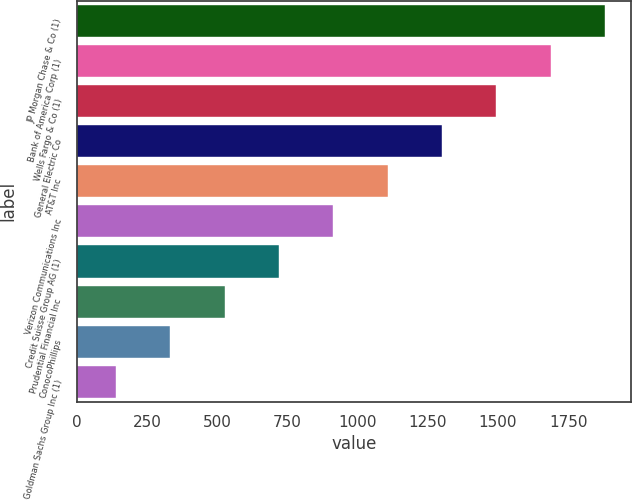Convert chart to OTSL. <chart><loc_0><loc_0><loc_500><loc_500><bar_chart><fcel>JP Morgan Chase & Co (1)<fcel>Bank of America Corp (1)<fcel>Wells Fargo & Co (1)<fcel>General Electric Co<fcel>AT&T Inc<fcel>Verizon Communications Inc<fcel>Credit Suisse Group AG (1)<fcel>Prudential Financial Inc<fcel>ConocoPhillips<fcel>Goldman Sachs Group Inc (1)<nl><fcel>1880.84<fcel>1687.38<fcel>1493.92<fcel>1300.46<fcel>1107<fcel>913.54<fcel>720.08<fcel>526.62<fcel>333.16<fcel>139.7<nl></chart> 